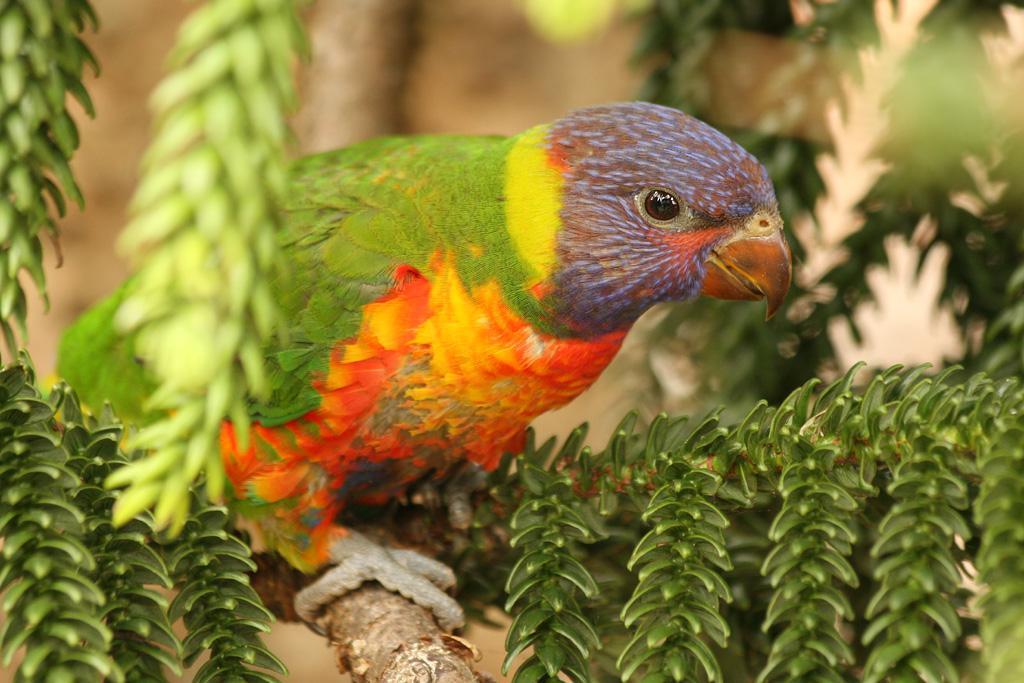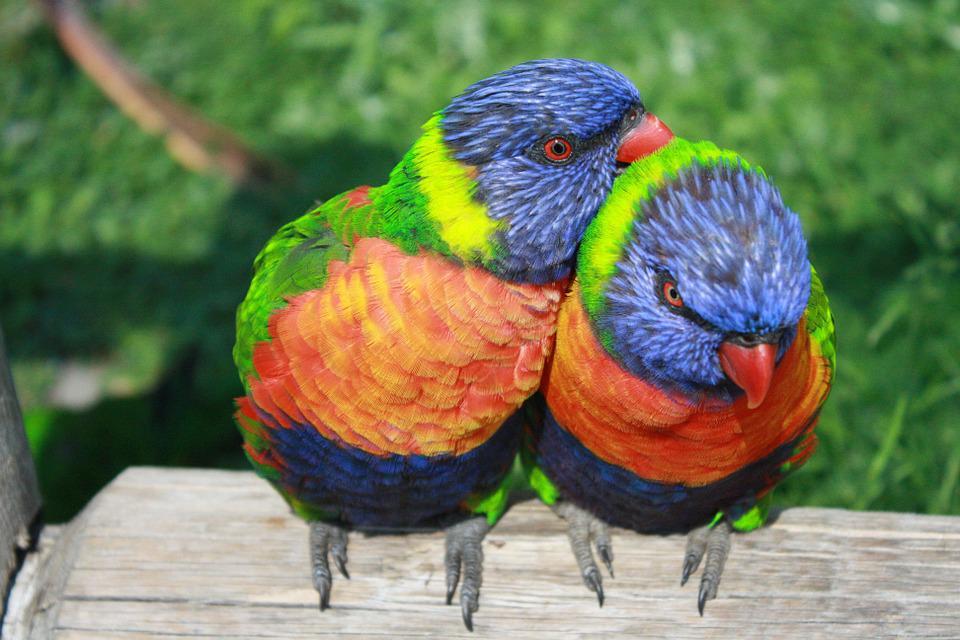The first image is the image on the left, the second image is the image on the right. Given the left and right images, does the statement "One image includes a colorful parrot with wide-spread wings." hold true? Answer yes or no. No. The first image is the image on the left, the second image is the image on the right. Assess this claim about the two images: "One photo shows a colorful bird with its wings spread". Correct or not? Answer yes or no. No. 